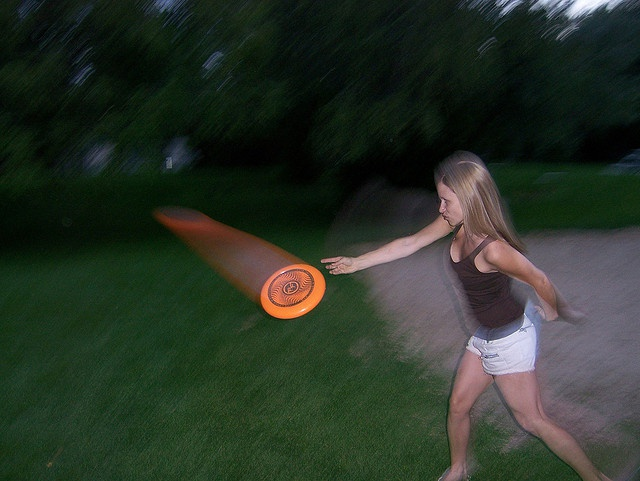Describe the objects in this image and their specific colors. I can see people in black, gray, and darkgray tones and frisbee in black, salmon, and brown tones in this image. 